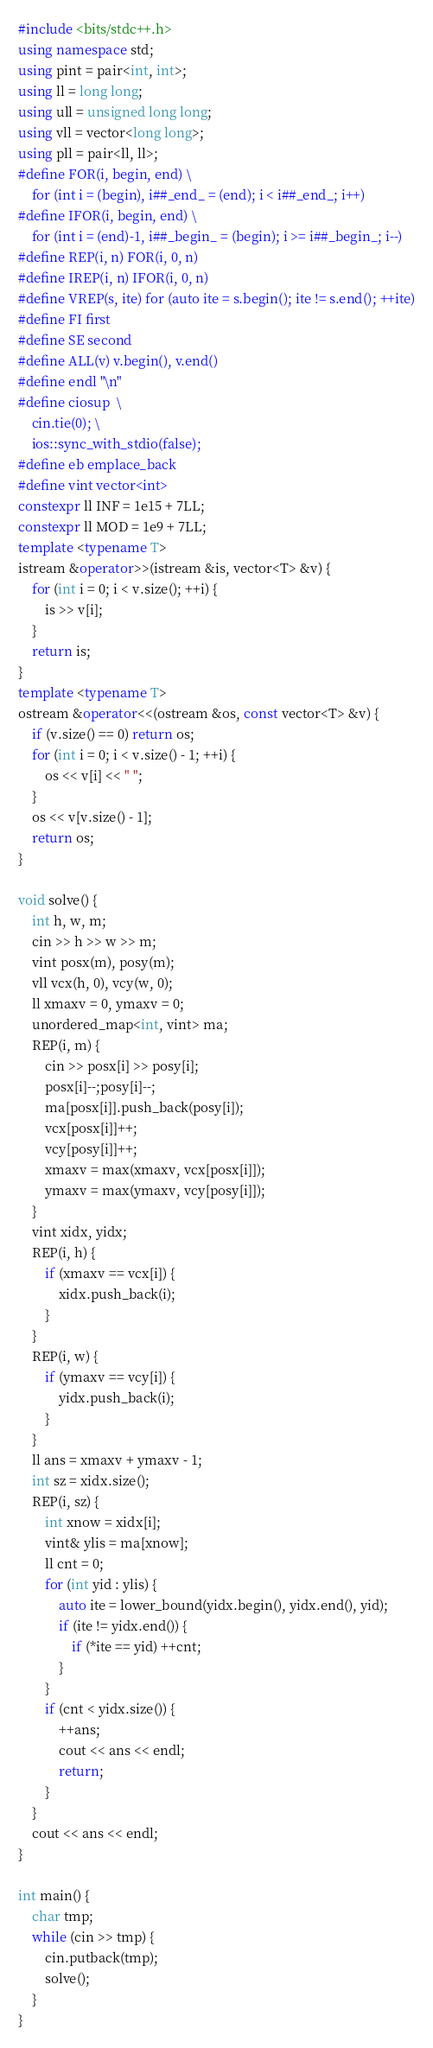Convert code to text. <code><loc_0><loc_0><loc_500><loc_500><_C++_>#include <bits/stdc++.h>
using namespace std;
using pint = pair<int, int>;
using ll = long long;
using ull = unsigned long long;
using vll = vector<long long>;
using pll = pair<ll, ll>;
#define FOR(i, begin, end) \
    for (int i = (begin), i##_end_ = (end); i < i##_end_; i++)
#define IFOR(i, begin, end) \
    for (int i = (end)-1, i##_begin_ = (begin); i >= i##_begin_; i--)
#define REP(i, n) FOR(i, 0, n)
#define IREP(i, n) IFOR(i, 0, n)
#define VREP(s, ite) for (auto ite = s.begin(); ite != s.end(); ++ite)
#define FI first
#define SE second
#define ALL(v) v.begin(), v.end()
#define endl "\n"
#define ciosup  \
    cin.tie(0); \
    ios::sync_with_stdio(false);
#define eb emplace_back
#define vint vector<int>
constexpr ll INF = 1e15 + 7LL;
constexpr ll MOD = 1e9 + 7LL;
template <typename T>
istream &operator>>(istream &is, vector<T> &v) {
    for (int i = 0; i < v.size(); ++i) {
        is >> v[i];
    }
    return is;
}
template <typename T>
ostream &operator<<(ostream &os, const vector<T> &v) {
    if (v.size() == 0) return os;
    for (int i = 0; i < v.size() - 1; ++i) {
        os << v[i] << " ";
    }
    os << v[v.size() - 1];
    return os;
}

void solve() {
    int h, w, m;
    cin >> h >> w >> m;
    vint posx(m), posy(m);
    vll vcx(h, 0), vcy(w, 0);
    ll xmaxv = 0, ymaxv = 0;
    unordered_map<int, vint> ma;
    REP(i, m) {
        cin >> posx[i] >> posy[i];
        posx[i]--;posy[i]--;
        ma[posx[i]].push_back(posy[i]);
        vcx[posx[i]]++;
        vcy[posy[i]]++;
        xmaxv = max(xmaxv, vcx[posx[i]]);
        ymaxv = max(ymaxv, vcy[posy[i]]);
    }
    vint xidx, yidx;
    REP(i, h) {
        if (xmaxv == vcx[i]) {
            xidx.push_back(i);
        }
    }
    REP(i, w) {
        if (ymaxv == vcy[i]) {
            yidx.push_back(i);
        }
    }
    ll ans = xmaxv + ymaxv - 1;
    int sz = xidx.size();
    REP(i, sz) {
        int xnow = xidx[i];
        vint& ylis = ma[xnow];
        ll cnt = 0;
        for (int yid : ylis) {
            auto ite = lower_bound(yidx.begin(), yidx.end(), yid);
            if (ite != yidx.end()) {
                if (*ite == yid) ++cnt;
            }
        }
        if (cnt < yidx.size()) {
            ++ans;
            cout << ans << endl;
            return;
        }
    }
    cout << ans << endl;
}

int main() {
    char tmp;
    while (cin >> tmp) {
        cin.putback(tmp);
        solve();
    }
}

</code> 